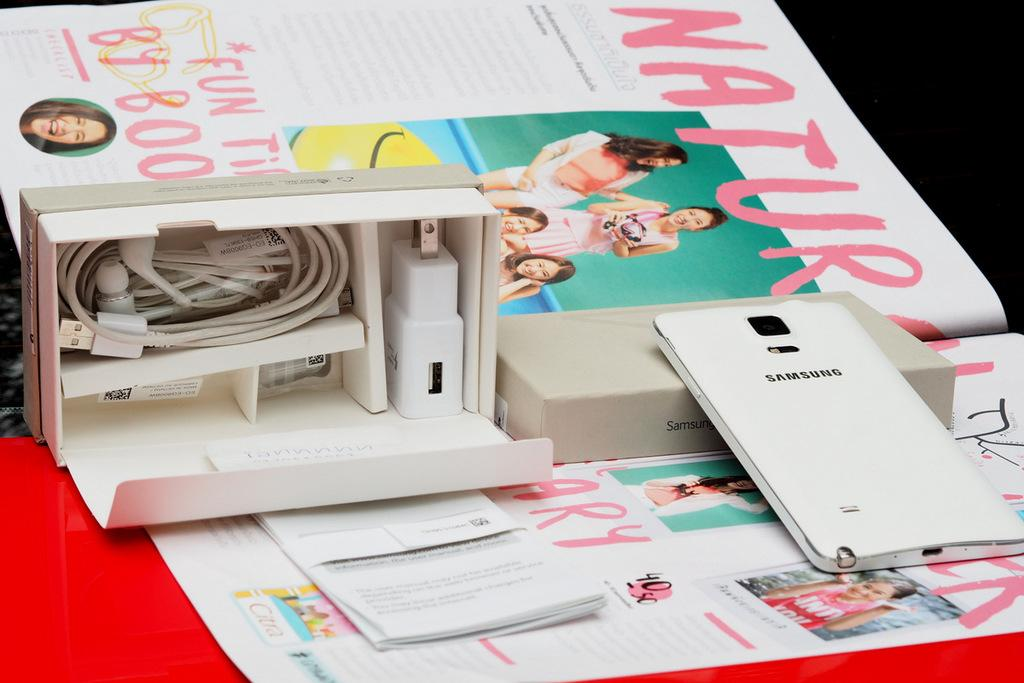What is the main object in the image? There is a mobile in the image. What is the packaging for the mobile? There is a mobile box in the image. What items are included in the mobile box? The mobile box contains an adaptor, earphones, and a charging cable. What is the purpose of the papers in the image? The papers are on an object, which suggests they might be used for documentation or instructions related to the mobile or its accessories. Can you see the bear playing with the earphones in the image? There is no bear present in the image, and therefore no such activity can be observed. How many toes are visible on the mobile in the image? The mobile is an electronic device and does not have toes; it is not a living organism. 